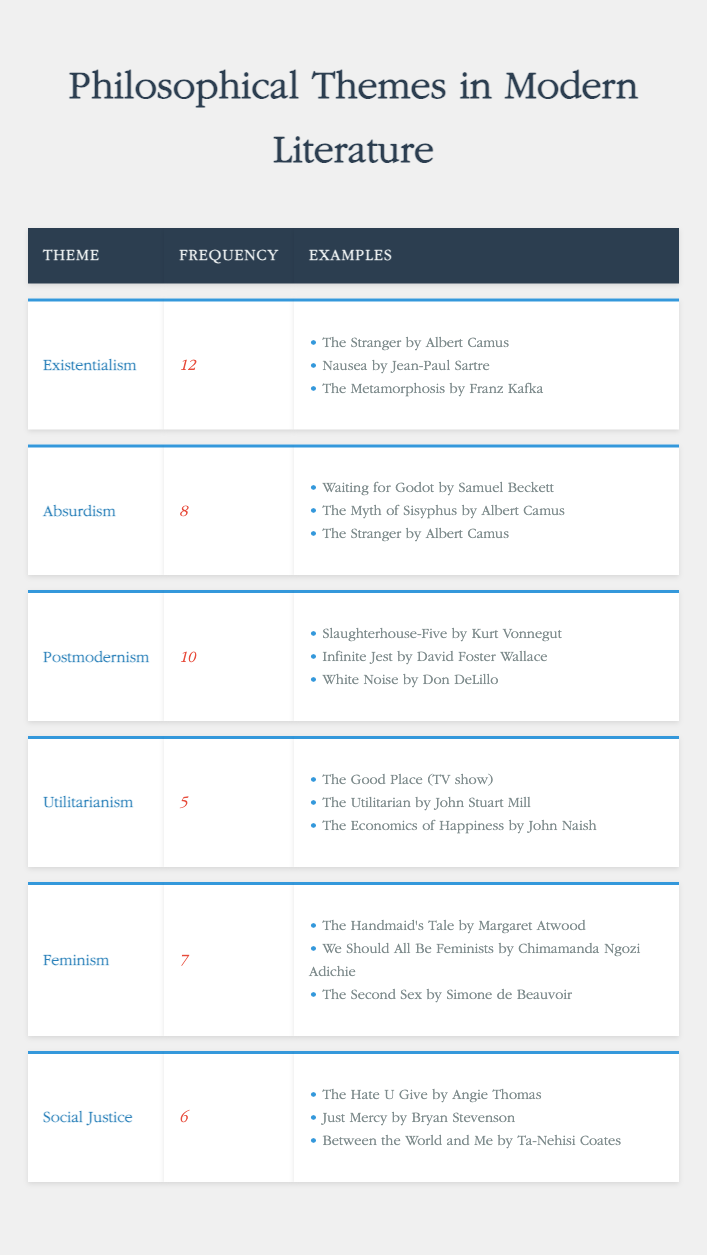What is the most frequent philosophical theme in modern literature? By examining the frequency column in the table, we see that "Existentialism" has the highest frequency of 12 compared to the other themes.
Answer: Existentialism How many examples are provided for the theme of feminism? Looking at the examples column under the theme "Feminism," there are three listed: "The Handmaid's Tale," "We Should All Be Feminists," and "The Second Sex." Thus, the count is 3.
Answer: 3 What is the total frequency of existentialism and absurdism combined? To find this, we add the frequencies of "Existentialism" (12) and "Absurdism" (8). The sum is 12 + 8 = 20.
Answer: 20 Is there a theme related to social justice with a higher frequency than that of utilitarianism? Comparing the frequencies, "Social Justice" has a frequency of 6 and "Utilitarianism" has 5; hence, 6 is greater than 5, confirming the statement is true.
Answer: Yes Which theme has an example that overlaps with absurdism? In the examples listed under "Absurdism," "The Stranger by Albert Camus" is also listed. To identify, we check if the same title appears in the examples of both themes.
Answer: The Stranger by Albert Camus What is the average frequency of the themes listed in the table? First, we add all frequencies: 12 + 8 + 10 + 5 + 7 + 6 = 48. There are 6 themes, so we divide the total frequency (48) by the number of themes (6): 48 / 6 = 8.
Answer: 8 Is feminism the only philosophical theme in the table that has a frequency below 8? The frequencies of feminism (7), social justice (6), and utilitarianism (5) are considered. Since there are multiple themes below 8, we determine that feminism is not the only one.
Answer: No What is the difference in frequency between the themes of postmodernism and existentialism? The frequency of "Postmodernism" is 10 and that of "Existentialism" is 12. By subtracting these values: 12 - 10 = 2, we find the difference.
Answer: 2 What theme has the least frequency, and what is its value? Checking the frequency values, "Utilitarianism" has the lowest frequency at 5, thus it is the theme with the least representation.
Answer: Utilitarianism, 5 